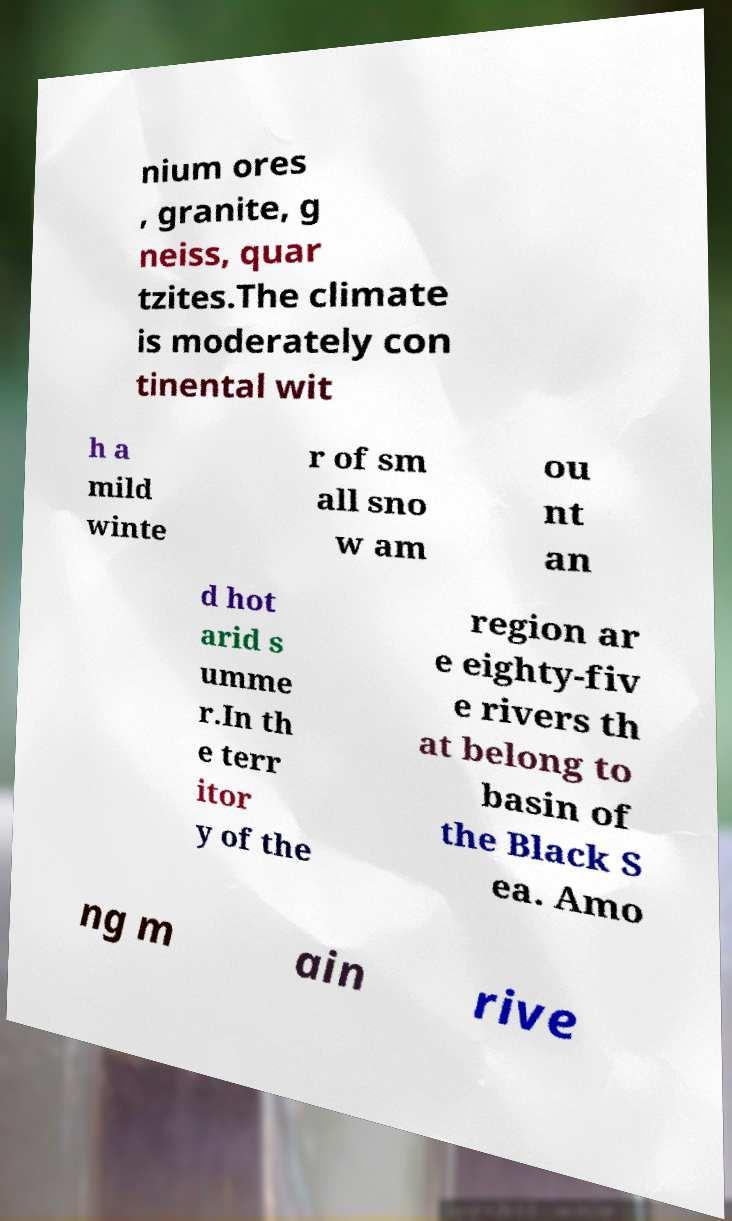There's text embedded in this image that I need extracted. Can you transcribe it verbatim? nium ores , granite, g neiss, quar tzites.The climate is moderately con tinental wit h a mild winte r of sm all sno w am ou nt an d hot arid s umme r.In th e terr itor y of the region ar e eighty-fiv e rivers th at belong to basin of the Black S ea. Amo ng m ain rive 